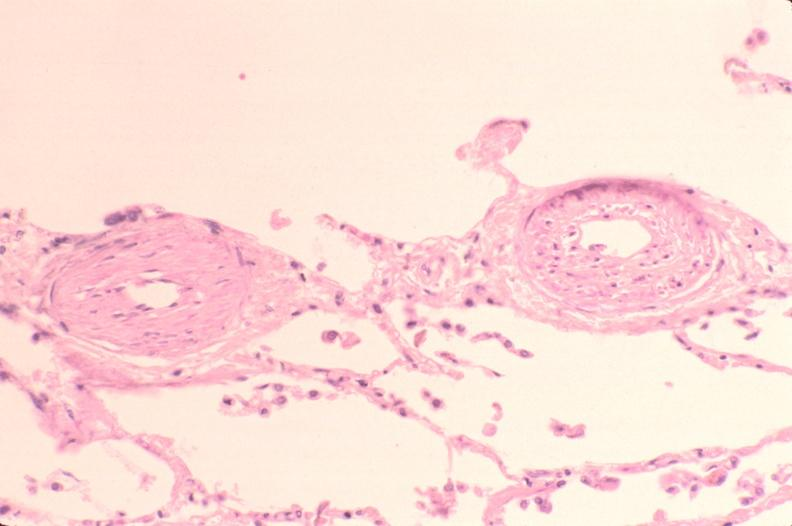what is present?
Answer the question using a single word or phrase. Respiratory 